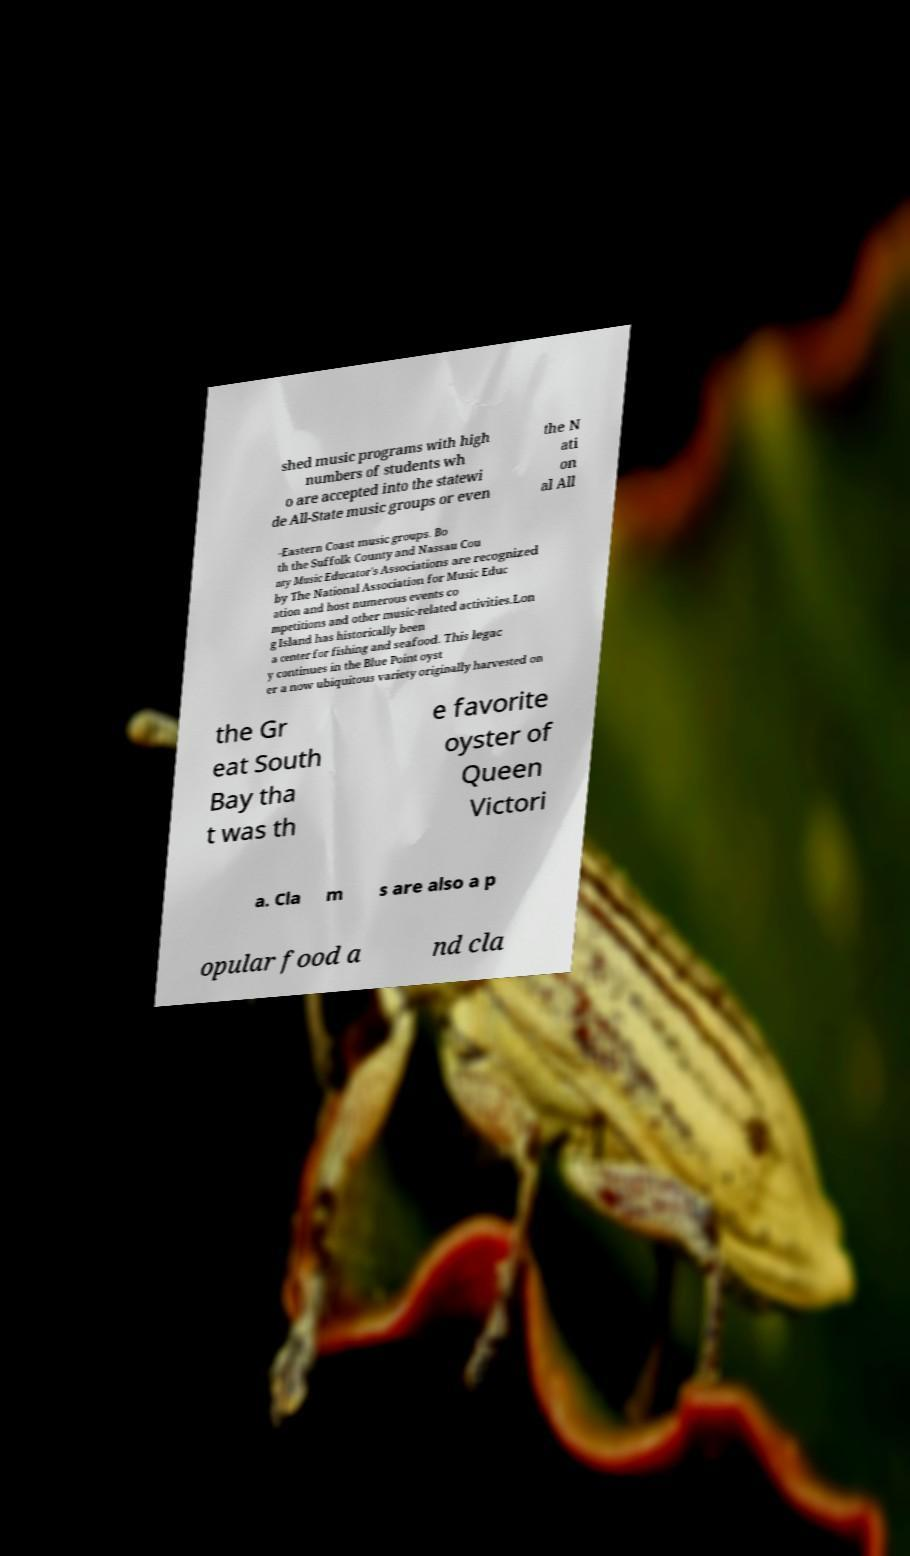I need the written content from this picture converted into text. Can you do that? shed music programs with high numbers of students wh o are accepted into the statewi de All-State music groups or even the N ati on al All -Eastern Coast music groups. Bo th the Suffolk County and Nassau Cou nty Music Educator's Associations are recognized by The National Association for Music Educ ation and host numerous events co mpetitions and other music-related activities.Lon g Island has historically been a center for fishing and seafood. This legac y continues in the Blue Point oyst er a now ubiquitous variety originally harvested on the Gr eat South Bay tha t was th e favorite oyster of Queen Victori a. Cla m s are also a p opular food a nd cla 